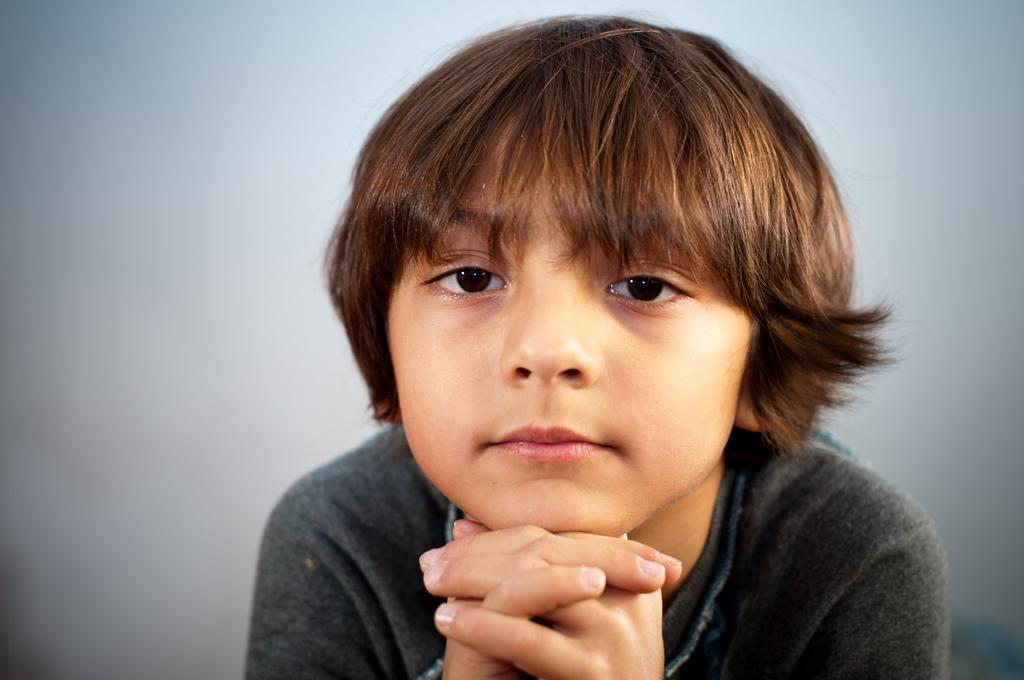Who or what is the main subject in the image? There is a person in the image. What is the person wearing? The person is wearing a black dress. What is the color of the background in the image? The background of the image is white. How many trains can be seen in the image? There are no trains present in the image. What type of fowl is visible in the image? There is no fowl present in the image. 